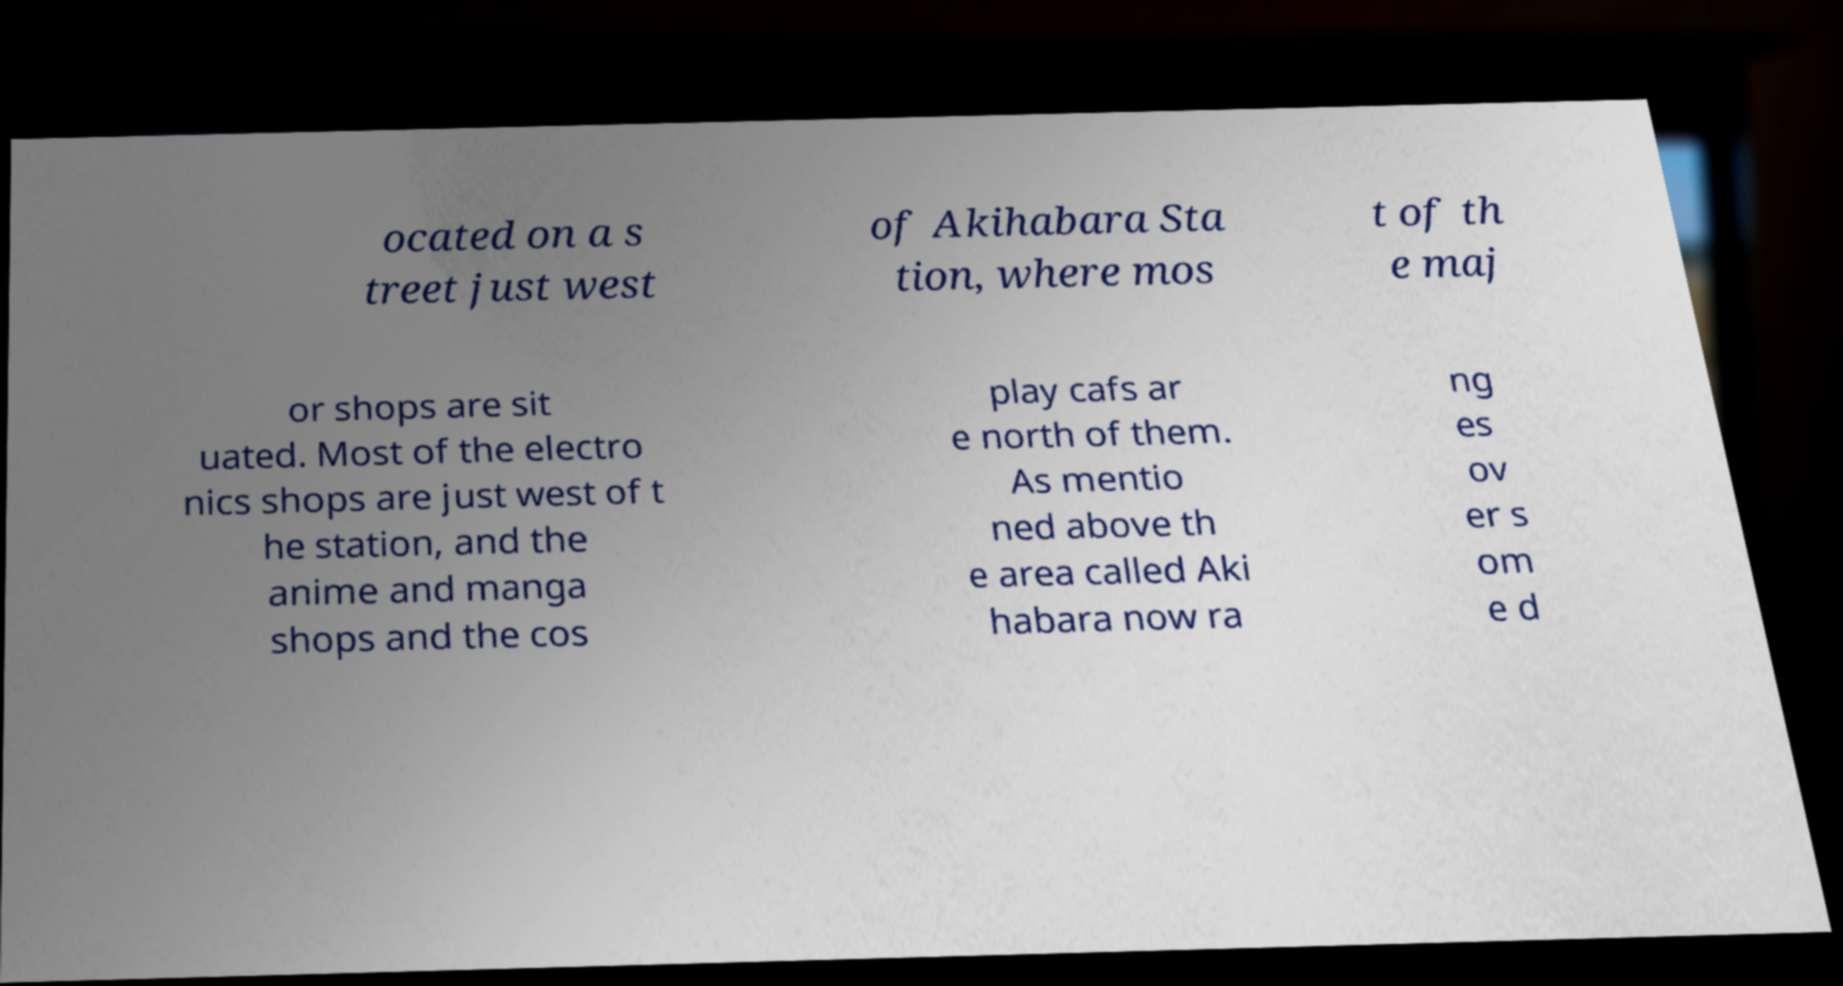There's text embedded in this image that I need extracted. Can you transcribe it verbatim? ocated on a s treet just west of Akihabara Sta tion, where mos t of th e maj or shops are sit uated. Most of the electro nics shops are just west of t he station, and the anime and manga shops and the cos play cafs ar e north of them. As mentio ned above th e area called Aki habara now ra ng es ov er s om e d 